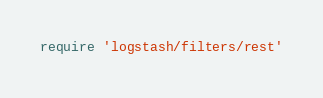Convert code to text. <code><loc_0><loc_0><loc_500><loc_500><_Ruby_>require 'logstash/filters/rest'</code> 